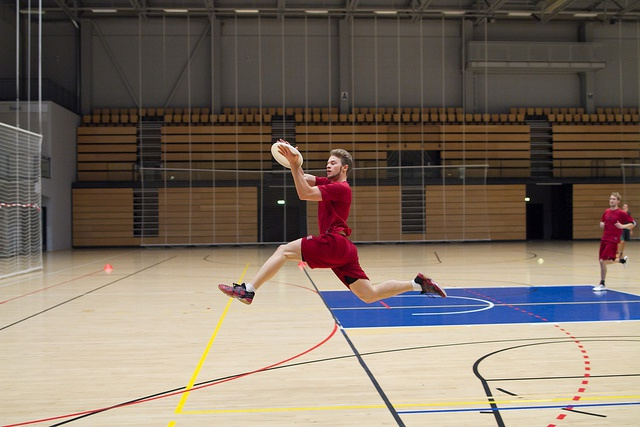Describe the objects in this image and their specific colors. I can see people in black, maroon, salmon, tan, and brown tones, people in black, maroon, gray, and brown tones, frisbee in black, tan, and lightgray tones, and people in black, gray, maroon, and tan tones in this image. 